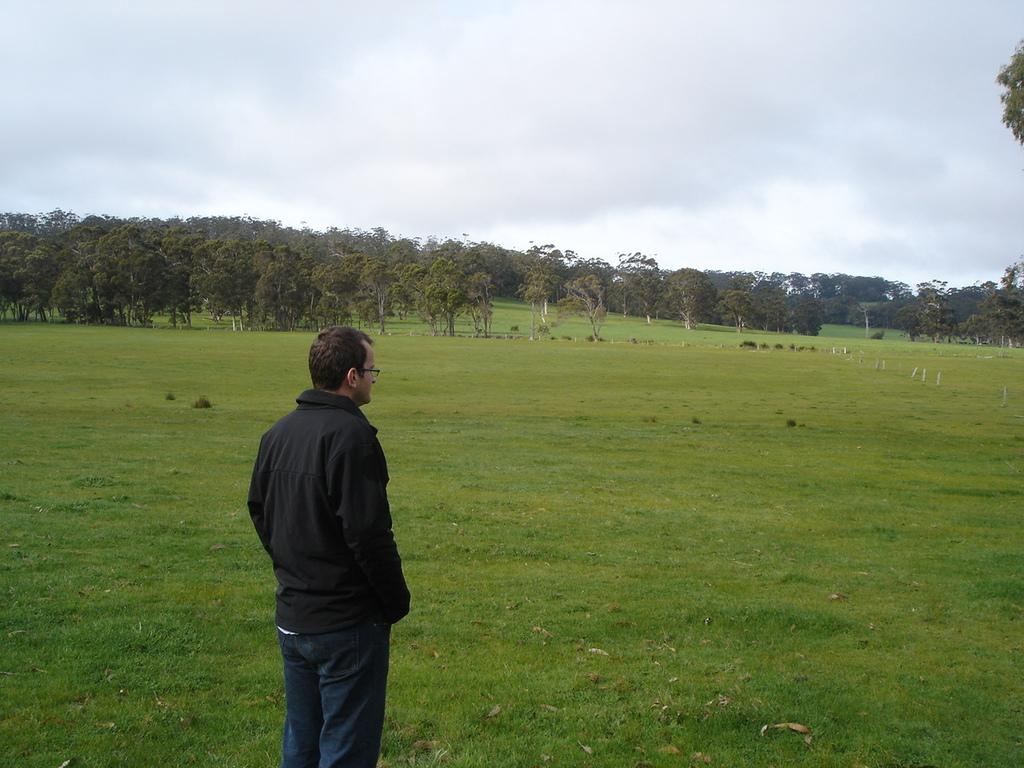What is the main subject of the image? There is a person standing in the image. What is the person standing on? The person is standing on grass. What can be seen in the background of the image? There is grass and trees visible in the background of the image. What type of cap is the person wearing in the image? There is no cap visible in the image; the person is not wearing any headgear. 